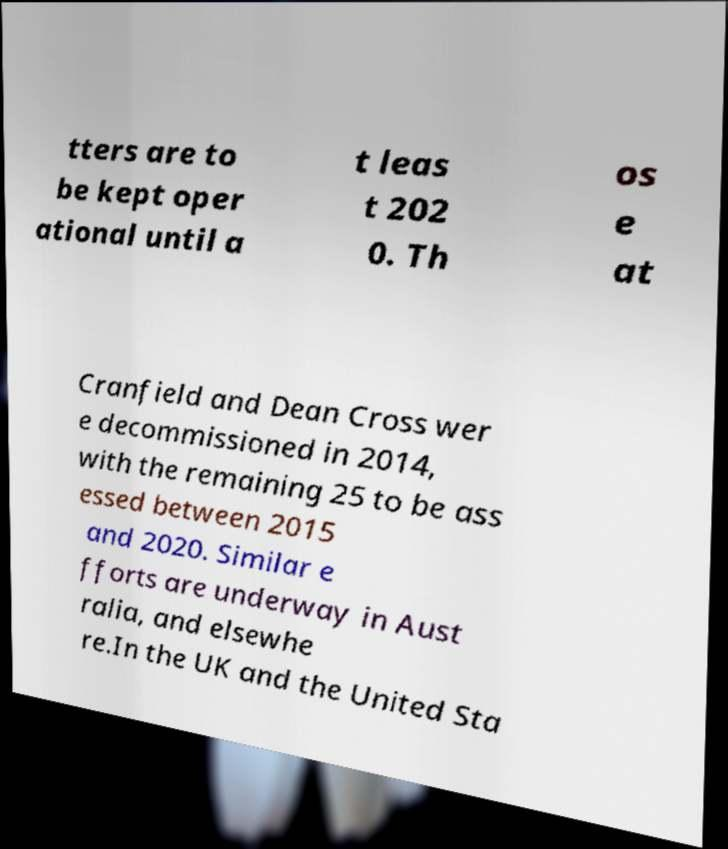I need the written content from this picture converted into text. Can you do that? tters are to be kept oper ational until a t leas t 202 0. Th os e at Cranfield and Dean Cross wer e decommissioned in 2014, with the remaining 25 to be ass essed between 2015 and 2020. Similar e fforts are underway in Aust ralia, and elsewhe re.In the UK and the United Sta 